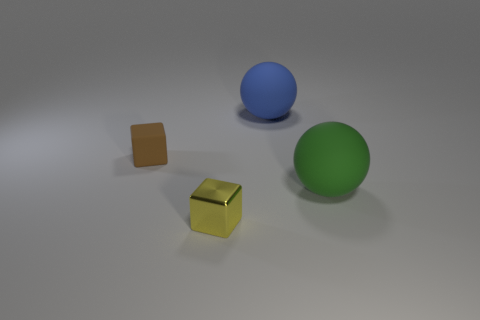There is a large matte object that is to the left of the green thing in front of the brown rubber block; what shape is it?
Make the answer very short. Sphere. Are there any other big spheres that have the same material as the big blue ball?
Ensure brevity in your answer.  Yes. There is a green matte object that is to the right of the brown thing; is its size the same as the brown cube?
Make the answer very short. No. What number of gray objects are tiny matte objects or big cylinders?
Offer a terse response. 0. What is the small object that is in front of the small matte block made of?
Give a very brief answer. Metal. How many big green objects are in front of the block that is behind the green rubber ball?
Offer a very short reply. 1. What number of tiny yellow things are the same shape as the brown matte thing?
Your answer should be very brief. 1. How many brown things are there?
Your answer should be very brief. 1. There is a big rubber object to the left of the green rubber thing; what is its color?
Make the answer very short. Blue. There is a object that is right of the large matte ball behind the large green rubber object; what is its color?
Give a very brief answer. Green. 